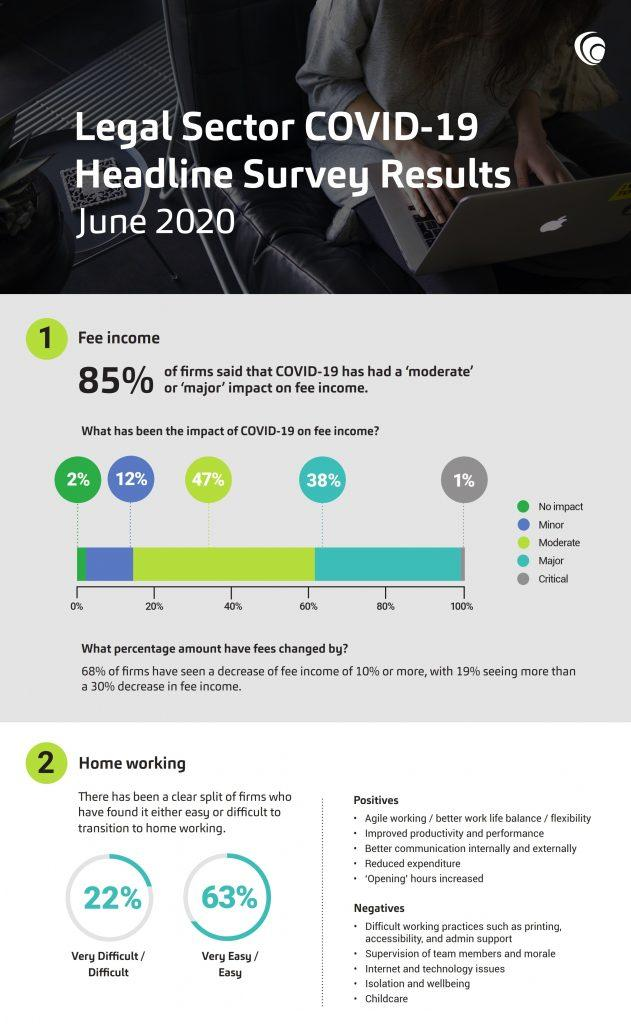Give some essential details in this illustration. Thirty-nine percent of the respondents reported that their organization has experienced a major or critical impact on fee income due to the pandemic. Home working, also known as agile working, has a positive impact on productivity and job satisfaction. According to the survey, 22% of respondents reported that finding a home while working remotely has been very difficult. Out of the total number of respondents who have had a minor or moderate impact on fee income, 59% reported a decrease in fee income. 